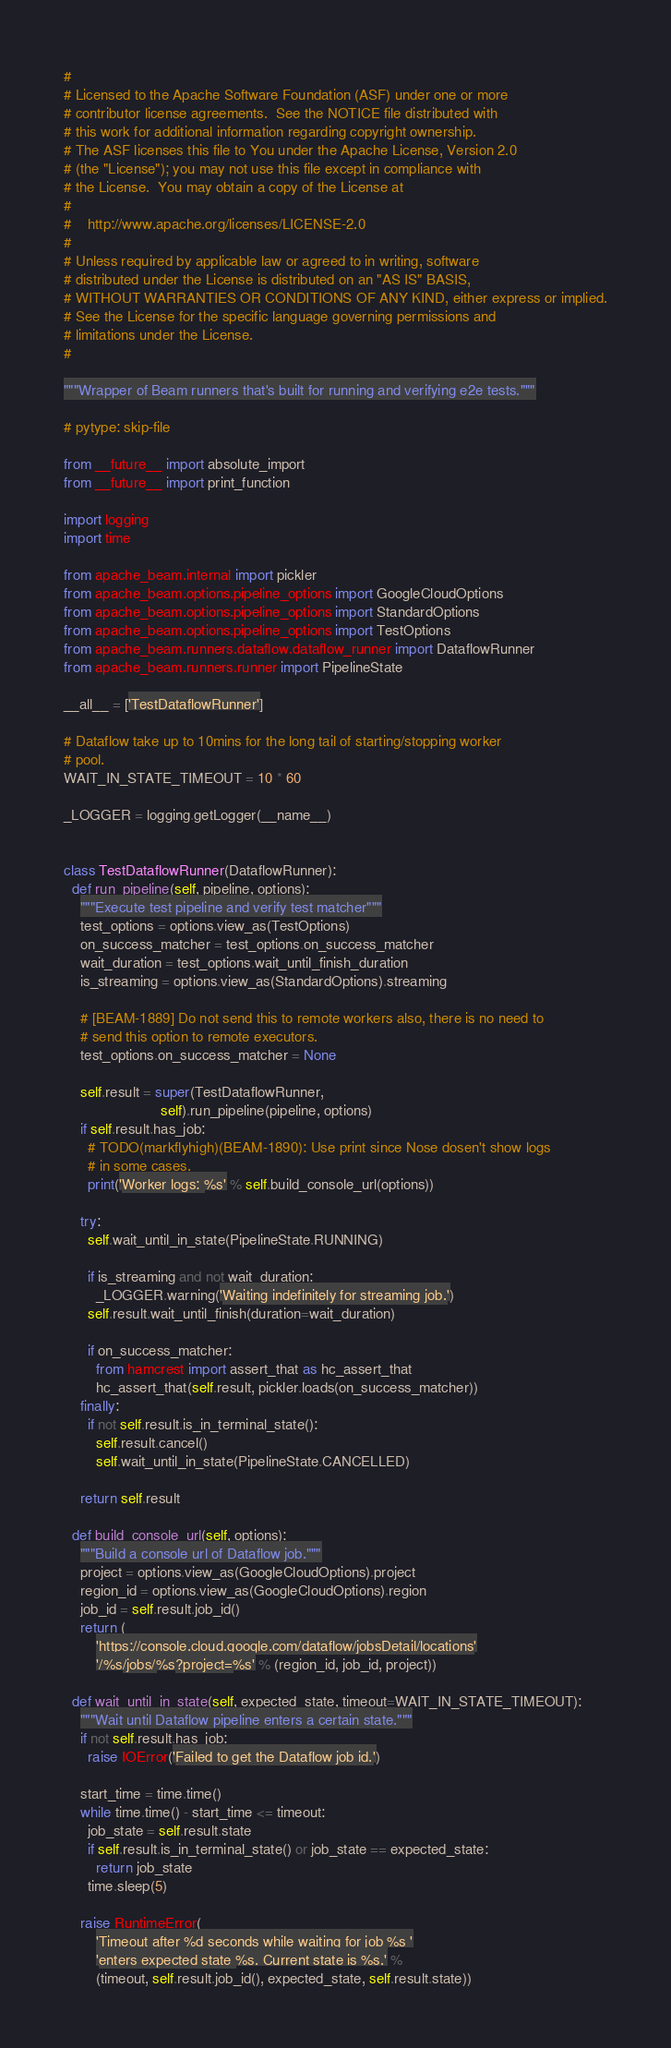<code> <loc_0><loc_0><loc_500><loc_500><_Python_>#
# Licensed to the Apache Software Foundation (ASF) under one or more
# contributor license agreements.  See the NOTICE file distributed with
# this work for additional information regarding copyright ownership.
# The ASF licenses this file to You under the Apache License, Version 2.0
# (the "License"); you may not use this file except in compliance with
# the License.  You may obtain a copy of the License at
#
#    http://www.apache.org/licenses/LICENSE-2.0
#
# Unless required by applicable law or agreed to in writing, software
# distributed under the License is distributed on an "AS IS" BASIS,
# WITHOUT WARRANTIES OR CONDITIONS OF ANY KIND, either express or implied.
# See the License for the specific language governing permissions and
# limitations under the License.
#

"""Wrapper of Beam runners that's built for running and verifying e2e tests."""

# pytype: skip-file

from __future__ import absolute_import
from __future__ import print_function

import logging
import time

from apache_beam.internal import pickler
from apache_beam.options.pipeline_options import GoogleCloudOptions
from apache_beam.options.pipeline_options import StandardOptions
from apache_beam.options.pipeline_options import TestOptions
from apache_beam.runners.dataflow.dataflow_runner import DataflowRunner
from apache_beam.runners.runner import PipelineState

__all__ = ['TestDataflowRunner']

# Dataflow take up to 10mins for the long tail of starting/stopping worker
# pool.
WAIT_IN_STATE_TIMEOUT = 10 * 60

_LOGGER = logging.getLogger(__name__)


class TestDataflowRunner(DataflowRunner):
  def run_pipeline(self, pipeline, options):
    """Execute test pipeline and verify test matcher"""
    test_options = options.view_as(TestOptions)
    on_success_matcher = test_options.on_success_matcher
    wait_duration = test_options.wait_until_finish_duration
    is_streaming = options.view_as(StandardOptions).streaming

    # [BEAM-1889] Do not send this to remote workers also, there is no need to
    # send this option to remote executors.
    test_options.on_success_matcher = None

    self.result = super(TestDataflowRunner,
                        self).run_pipeline(pipeline, options)
    if self.result.has_job:
      # TODO(markflyhigh)(BEAM-1890): Use print since Nose dosen't show logs
      # in some cases.
      print('Worker logs: %s' % self.build_console_url(options))

    try:
      self.wait_until_in_state(PipelineState.RUNNING)

      if is_streaming and not wait_duration:
        _LOGGER.warning('Waiting indefinitely for streaming job.')
      self.result.wait_until_finish(duration=wait_duration)

      if on_success_matcher:
        from hamcrest import assert_that as hc_assert_that
        hc_assert_that(self.result, pickler.loads(on_success_matcher))
    finally:
      if not self.result.is_in_terminal_state():
        self.result.cancel()
        self.wait_until_in_state(PipelineState.CANCELLED)

    return self.result

  def build_console_url(self, options):
    """Build a console url of Dataflow job."""
    project = options.view_as(GoogleCloudOptions).project
    region_id = options.view_as(GoogleCloudOptions).region
    job_id = self.result.job_id()
    return (
        'https://console.cloud.google.com/dataflow/jobsDetail/locations'
        '/%s/jobs/%s?project=%s' % (region_id, job_id, project))

  def wait_until_in_state(self, expected_state, timeout=WAIT_IN_STATE_TIMEOUT):
    """Wait until Dataflow pipeline enters a certain state."""
    if not self.result.has_job:
      raise IOError('Failed to get the Dataflow job id.')

    start_time = time.time()
    while time.time() - start_time <= timeout:
      job_state = self.result.state
      if self.result.is_in_terminal_state() or job_state == expected_state:
        return job_state
      time.sleep(5)

    raise RuntimeError(
        'Timeout after %d seconds while waiting for job %s '
        'enters expected state %s. Current state is %s.' %
        (timeout, self.result.job_id(), expected_state, self.result.state))
</code> 